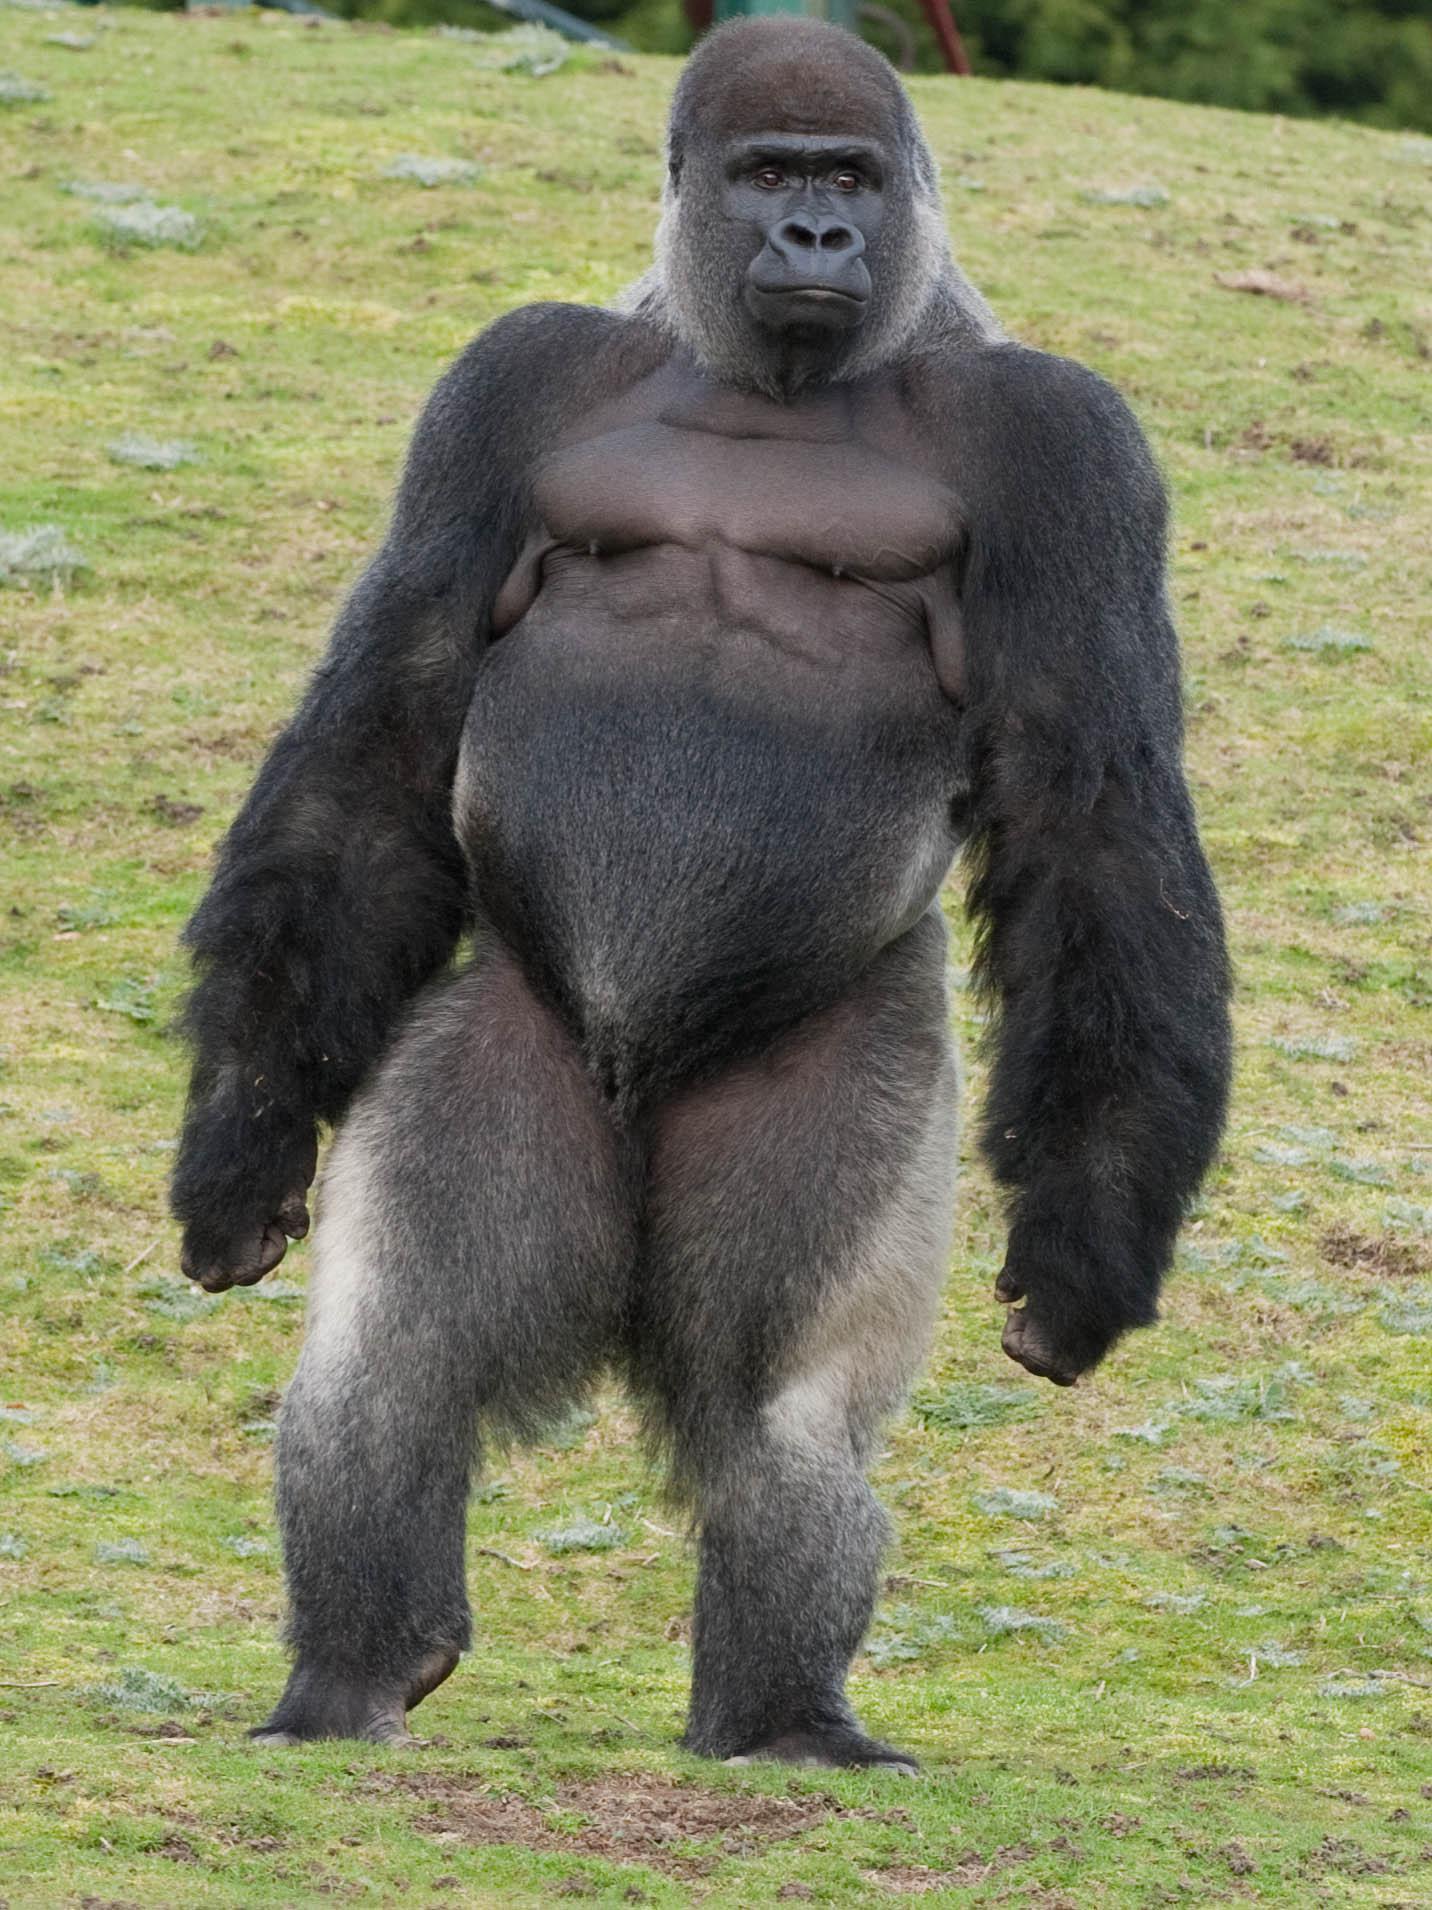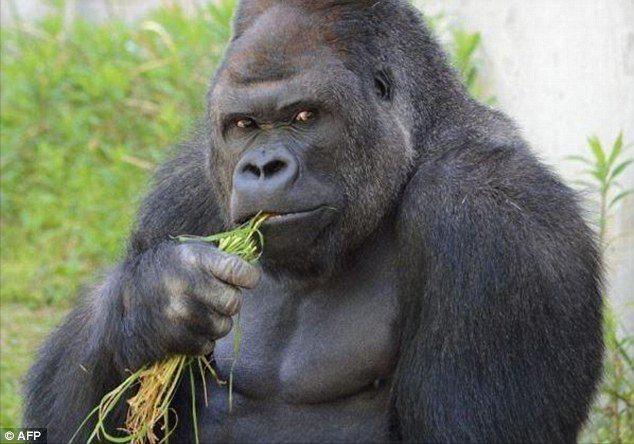The first image is the image on the left, the second image is the image on the right. Assess this claim about the two images: "A concrete barrier can be seen behind the ape in the image on the left.". Correct or not? Answer yes or no. No. The first image is the image on the left, the second image is the image on the right. Evaluate the accuracy of this statement regarding the images: "One image shows a gorilla standing up straight, and the other shows a gorilla turning its head to eye the camera, with one elbow bent and hand near its chin.". Is it true? Answer yes or no. Yes. 